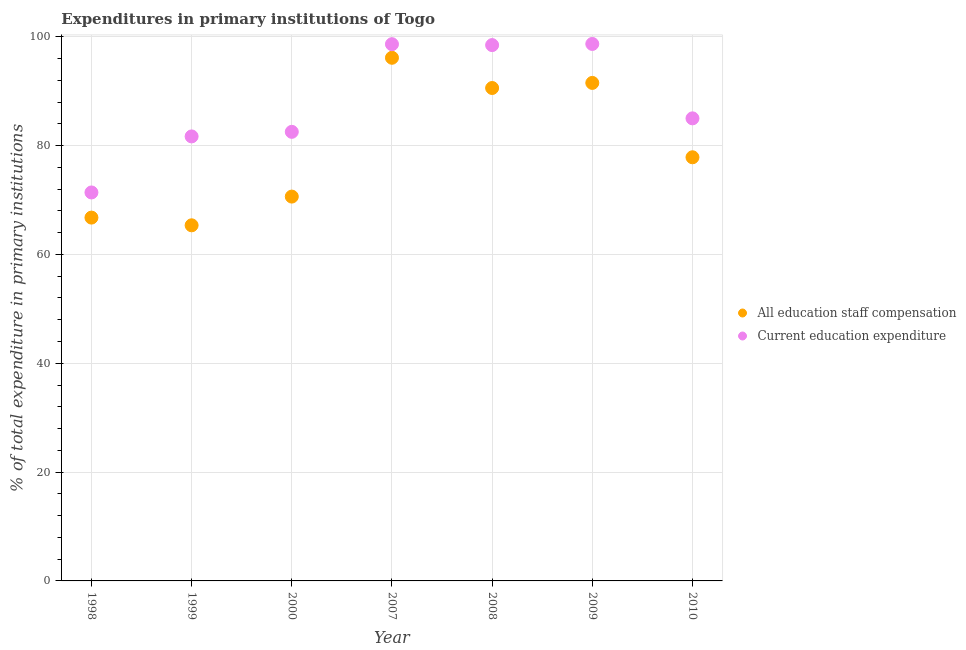How many different coloured dotlines are there?
Your answer should be very brief. 2. What is the expenditure in education in 2009?
Provide a succinct answer. 98.67. Across all years, what is the maximum expenditure in staff compensation?
Your answer should be very brief. 96.13. Across all years, what is the minimum expenditure in staff compensation?
Give a very brief answer. 65.34. In which year was the expenditure in staff compensation maximum?
Offer a terse response. 2007. What is the total expenditure in staff compensation in the graph?
Ensure brevity in your answer.  558.79. What is the difference between the expenditure in staff compensation in 2009 and that in 2010?
Provide a succinct answer. 13.66. What is the difference between the expenditure in education in 1999 and the expenditure in staff compensation in 2009?
Offer a very short reply. -9.83. What is the average expenditure in education per year?
Ensure brevity in your answer.  88.05. In the year 2010, what is the difference between the expenditure in staff compensation and expenditure in education?
Provide a short and direct response. -7.15. In how many years, is the expenditure in education greater than 68 %?
Your answer should be compact. 7. What is the ratio of the expenditure in education in 2000 to that in 2008?
Make the answer very short. 0.84. Is the expenditure in staff compensation in 2007 less than that in 2008?
Offer a very short reply. No. Is the difference between the expenditure in education in 1998 and 2009 greater than the difference between the expenditure in staff compensation in 1998 and 2009?
Your answer should be very brief. No. What is the difference between the highest and the second highest expenditure in education?
Your answer should be very brief. 0.04. What is the difference between the highest and the lowest expenditure in education?
Your answer should be compact. 27.29. In how many years, is the expenditure in staff compensation greater than the average expenditure in staff compensation taken over all years?
Provide a short and direct response. 3. Is the sum of the expenditure in education in 2000 and 2008 greater than the maximum expenditure in staff compensation across all years?
Offer a very short reply. Yes. How many years are there in the graph?
Provide a short and direct response. 7. Where does the legend appear in the graph?
Ensure brevity in your answer.  Center right. How are the legend labels stacked?
Give a very brief answer. Vertical. What is the title of the graph?
Make the answer very short. Expenditures in primary institutions of Togo. Does "Nitrous oxide" appear as one of the legend labels in the graph?
Offer a very short reply. No. What is the label or title of the X-axis?
Make the answer very short. Year. What is the label or title of the Y-axis?
Offer a very short reply. % of total expenditure in primary institutions. What is the % of total expenditure in primary institutions in All education staff compensation in 1998?
Ensure brevity in your answer.  66.76. What is the % of total expenditure in primary institutions of Current education expenditure in 1998?
Your answer should be compact. 71.38. What is the % of total expenditure in primary institutions in All education staff compensation in 1999?
Provide a succinct answer. 65.34. What is the % of total expenditure in primary institutions in Current education expenditure in 1999?
Make the answer very short. 81.68. What is the % of total expenditure in primary institutions in All education staff compensation in 2000?
Your answer should be very brief. 70.62. What is the % of total expenditure in primary institutions of Current education expenditure in 2000?
Your response must be concise. 82.52. What is the % of total expenditure in primary institutions in All education staff compensation in 2007?
Give a very brief answer. 96.13. What is the % of total expenditure in primary institutions in Current education expenditure in 2007?
Your answer should be very brief. 98.63. What is the % of total expenditure in primary institutions of All education staff compensation in 2008?
Provide a succinct answer. 90.57. What is the % of total expenditure in primary institutions in Current education expenditure in 2008?
Your response must be concise. 98.46. What is the % of total expenditure in primary institutions in All education staff compensation in 2009?
Offer a very short reply. 91.51. What is the % of total expenditure in primary institutions of Current education expenditure in 2009?
Give a very brief answer. 98.67. What is the % of total expenditure in primary institutions in All education staff compensation in 2010?
Offer a terse response. 77.85. What is the % of total expenditure in primary institutions of Current education expenditure in 2010?
Offer a very short reply. 85. Across all years, what is the maximum % of total expenditure in primary institutions in All education staff compensation?
Your response must be concise. 96.13. Across all years, what is the maximum % of total expenditure in primary institutions of Current education expenditure?
Provide a short and direct response. 98.67. Across all years, what is the minimum % of total expenditure in primary institutions in All education staff compensation?
Offer a terse response. 65.34. Across all years, what is the minimum % of total expenditure in primary institutions of Current education expenditure?
Provide a short and direct response. 71.38. What is the total % of total expenditure in primary institutions of All education staff compensation in the graph?
Your response must be concise. 558.79. What is the total % of total expenditure in primary institutions in Current education expenditure in the graph?
Your response must be concise. 616.34. What is the difference between the % of total expenditure in primary institutions in All education staff compensation in 1998 and that in 1999?
Make the answer very short. 1.42. What is the difference between the % of total expenditure in primary institutions of Current education expenditure in 1998 and that in 1999?
Offer a terse response. -10.3. What is the difference between the % of total expenditure in primary institutions in All education staff compensation in 1998 and that in 2000?
Offer a terse response. -3.86. What is the difference between the % of total expenditure in primary institutions in Current education expenditure in 1998 and that in 2000?
Offer a terse response. -11.14. What is the difference between the % of total expenditure in primary institutions of All education staff compensation in 1998 and that in 2007?
Your answer should be very brief. -29.37. What is the difference between the % of total expenditure in primary institutions of Current education expenditure in 1998 and that in 2007?
Keep it short and to the point. -27.25. What is the difference between the % of total expenditure in primary institutions of All education staff compensation in 1998 and that in 2008?
Provide a short and direct response. -23.81. What is the difference between the % of total expenditure in primary institutions in Current education expenditure in 1998 and that in 2008?
Your answer should be compact. -27.08. What is the difference between the % of total expenditure in primary institutions of All education staff compensation in 1998 and that in 2009?
Ensure brevity in your answer.  -24.75. What is the difference between the % of total expenditure in primary institutions of Current education expenditure in 1998 and that in 2009?
Make the answer very short. -27.29. What is the difference between the % of total expenditure in primary institutions in All education staff compensation in 1998 and that in 2010?
Your answer should be very brief. -11.08. What is the difference between the % of total expenditure in primary institutions of Current education expenditure in 1998 and that in 2010?
Give a very brief answer. -13.62. What is the difference between the % of total expenditure in primary institutions of All education staff compensation in 1999 and that in 2000?
Your answer should be compact. -5.28. What is the difference between the % of total expenditure in primary institutions in Current education expenditure in 1999 and that in 2000?
Ensure brevity in your answer.  -0.84. What is the difference between the % of total expenditure in primary institutions of All education staff compensation in 1999 and that in 2007?
Make the answer very short. -30.78. What is the difference between the % of total expenditure in primary institutions of Current education expenditure in 1999 and that in 2007?
Offer a very short reply. -16.95. What is the difference between the % of total expenditure in primary institutions in All education staff compensation in 1999 and that in 2008?
Offer a very short reply. -25.23. What is the difference between the % of total expenditure in primary institutions in Current education expenditure in 1999 and that in 2008?
Keep it short and to the point. -16.78. What is the difference between the % of total expenditure in primary institutions of All education staff compensation in 1999 and that in 2009?
Your answer should be very brief. -26.17. What is the difference between the % of total expenditure in primary institutions of Current education expenditure in 1999 and that in 2009?
Make the answer very short. -16.99. What is the difference between the % of total expenditure in primary institutions in All education staff compensation in 1999 and that in 2010?
Keep it short and to the point. -12.5. What is the difference between the % of total expenditure in primary institutions in Current education expenditure in 1999 and that in 2010?
Give a very brief answer. -3.32. What is the difference between the % of total expenditure in primary institutions of All education staff compensation in 2000 and that in 2007?
Offer a terse response. -25.51. What is the difference between the % of total expenditure in primary institutions of Current education expenditure in 2000 and that in 2007?
Keep it short and to the point. -16.11. What is the difference between the % of total expenditure in primary institutions of All education staff compensation in 2000 and that in 2008?
Keep it short and to the point. -19.95. What is the difference between the % of total expenditure in primary institutions of Current education expenditure in 2000 and that in 2008?
Provide a short and direct response. -15.94. What is the difference between the % of total expenditure in primary institutions in All education staff compensation in 2000 and that in 2009?
Your answer should be compact. -20.89. What is the difference between the % of total expenditure in primary institutions in Current education expenditure in 2000 and that in 2009?
Offer a very short reply. -16.15. What is the difference between the % of total expenditure in primary institutions in All education staff compensation in 2000 and that in 2010?
Ensure brevity in your answer.  -7.22. What is the difference between the % of total expenditure in primary institutions of Current education expenditure in 2000 and that in 2010?
Your response must be concise. -2.48. What is the difference between the % of total expenditure in primary institutions of All education staff compensation in 2007 and that in 2008?
Keep it short and to the point. 5.56. What is the difference between the % of total expenditure in primary institutions in Current education expenditure in 2007 and that in 2008?
Offer a terse response. 0.17. What is the difference between the % of total expenditure in primary institutions of All education staff compensation in 2007 and that in 2009?
Your answer should be very brief. 4.62. What is the difference between the % of total expenditure in primary institutions in Current education expenditure in 2007 and that in 2009?
Ensure brevity in your answer.  -0.04. What is the difference between the % of total expenditure in primary institutions in All education staff compensation in 2007 and that in 2010?
Make the answer very short. 18.28. What is the difference between the % of total expenditure in primary institutions in Current education expenditure in 2007 and that in 2010?
Make the answer very short. 13.63. What is the difference between the % of total expenditure in primary institutions in All education staff compensation in 2008 and that in 2009?
Give a very brief answer. -0.94. What is the difference between the % of total expenditure in primary institutions in Current education expenditure in 2008 and that in 2009?
Give a very brief answer. -0.21. What is the difference between the % of total expenditure in primary institutions in All education staff compensation in 2008 and that in 2010?
Your response must be concise. 12.73. What is the difference between the % of total expenditure in primary institutions of Current education expenditure in 2008 and that in 2010?
Your answer should be compact. 13.46. What is the difference between the % of total expenditure in primary institutions of All education staff compensation in 2009 and that in 2010?
Make the answer very short. 13.66. What is the difference between the % of total expenditure in primary institutions in Current education expenditure in 2009 and that in 2010?
Make the answer very short. 13.67. What is the difference between the % of total expenditure in primary institutions of All education staff compensation in 1998 and the % of total expenditure in primary institutions of Current education expenditure in 1999?
Offer a terse response. -14.92. What is the difference between the % of total expenditure in primary institutions of All education staff compensation in 1998 and the % of total expenditure in primary institutions of Current education expenditure in 2000?
Provide a short and direct response. -15.76. What is the difference between the % of total expenditure in primary institutions of All education staff compensation in 1998 and the % of total expenditure in primary institutions of Current education expenditure in 2007?
Your answer should be compact. -31.86. What is the difference between the % of total expenditure in primary institutions of All education staff compensation in 1998 and the % of total expenditure in primary institutions of Current education expenditure in 2008?
Make the answer very short. -31.7. What is the difference between the % of total expenditure in primary institutions of All education staff compensation in 1998 and the % of total expenditure in primary institutions of Current education expenditure in 2009?
Offer a terse response. -31.91. What is the difference between the % of total expenditure in primary institutions of All education staff compensation in 1998 and the % of total expenditure in primary institutions of Current education expenditure in 2010?
Ensure brevity in your answer.  -18.24. What is the difference between the % of total expenditure in primary institutions of All education staff compensation in 1999 and the % of total expenditure in primary institutions of Current education expenditure in 2000?
Provide a short and direct response. -17.18. What is the difference between the % of total expenditure in primary institutions in All education staff compensation in 1999 and the % of total expenditure in primary institutions in Current education expenditure in 2007?
Your answer should be compact. -33.28. What is the difference between the % of total expenditure in primary institutions in All education staff compensation in 1999 and the % of total expenditure in primary institutions in Current education expenditure in 2008?
Your answer should be compact. -33.12. What is the difference between the % of total expenditure in primary institutions of All education staff compensation in 1999 and the % of total expenditure in primary institutions of Current education expenditure in 2009?
Your answer should be compact. -33.33. What is the difference between the % of total expenditure in primary institutions of All education staff compensation in 1999 and the % of total expenditure in primary institutions of Current education expenditure in 2010?
Offer a very short reply. -19.65. What is the difference between the % of total expenditure in primary institutions in All education staff compensation in 2000 and the % of total expenditure in primary institutions in Current education expenditure in 2007?
Provide a short and direct response. -28. What is the difference between the % of total expenditure in primary institutions in All education staff compensation in 2000 and the % of total expenditure in primary institutions in Current education expenditure in 2008?
Offer a terse response. -27.84. What is the difference between the % of total expenditure in primary institutions of All education staff compensation in 2000 and the % of total expenditure in primary institutions of Current education expenditure in 2009?
Offer a terse response. -28.05. What is the difference between the % of total expenditure in primary institutions of All education staff compensation in 2000 and the % of total expenditure in primary institutions of Current education expenditure in 2010?
Provide a short and direct response. -14.38. What is the difference between the % of total expenditure in primary institutions of All education staff compensation in 2007 and the % of total expenditure in primary institutions of Current education expenditure in 2008?
Give a very brief answer. -2.33. What is the difference between the % of total expenditure in primary institutions in All education staff compensation in 2007 and the % of total expenditure in primary institutions in Current education expenditure in 2009?
Give a very brief answer. -2.54. What is the difference between the % of total expenditure in primary institutions of All education staff compensation in 2007 and the % of total expenditure in primary institutions of Current education expenditure in 2010?
Ensure brevity in your answer.  11.13. What is the difference between the % of total expenditure in primary institutions of All education staff compensation in 2008 and the % of total expenditure in primary institutions of Current education expenditure in 2009?
Ensure brevity in your answer.  -8.1. What is the difference between the % of total expenditure in primary institutions in All education staff compensation in 2008 and the % of total expenditure in primary institutions in Current education expenditure in 2010?
Your answer should be very brief. 5.58. What is the difference between the % of total expenditure in primary institutions in All education staff compensation in 2009 and the % of total expenditure in primary institutions in Current education expenditure in 2010?
Your answer should be compact. 6.51. What is the average % of total expenditure in primary institutions in All education staff compensation per year?
Your answer should be very brief. 79.83. What is the average % of total expenditure in primary institutions of Current education expenditure per year?
Your answer should be very brief. 88.05. In the year 1998, what is the difference between the % of total expenditure in primary institutions of All education staff compensation and % of total expenditure in primary institutions of Current education expenditure?
Ensure brevity in your answer.  -4.62. In the year 1999, what is the difference between the % of total expenditure in primary institutions of All education staff compensation and % of total expenditure in primary institutions of Current education expenditure?
Provide a short and direct response. -16.34. In the year 2000, what is the difference between the % of total expenditure in primary institutions in All education staff compensation and % of total expenditure in primary institutions in Current education expenditure?
Your answer should be very brief. -11.9. In the year 2007, what is the difference between the % of total expenditure in primary institutions of All education staff compensation and % of total expenditure in primary institutions of Current education expenditure?
Offer a very short reply. -2.5. In the year 2008, what is the difference between the % of total expenditure in primary institutions of All education staff compensation and % of total expenditure in primary institutions of Current education expenditure?
Make the answer very short. -7.89. In the year 2009, what is the difference between the % of total expenditure in primary institutions of All education staff compensation and % of total expenditure in primary institutions of Current education expenditure?
Your answer should be very brief. -7.16. In the year 2010, what is the difference between the % of total expenditure in primary institutions of All education staff compensation and % of total expenditure in primary institutions of Current education expenditure?
Make the answer very short. -7.15. What is the ratio of the % of total expenditure in primary institutions of All education staff compensation in 1998 to that in 1999?
Ensure brevity in your answer.  1.02. What is the ratio of the % of total expenditure in primary institutions in Current education expenditure in 1998 to that in 1999?
Provide a succinct answer. 0.87. What is the ratio of the % of total expenditure in primary institutions in All education staff compensation in 1998 to that in 2000?
Your answer should be very brief. 0.95. What is the ratio of the % of total expenditure in primary institutions in Current education expenditure in 1998 to that in 2000?
Offer a terse response. 0.86. What is the ratio of the % of total expenditure in primary institutions of All education staff compensation in 1998 to that in 2007?
Offer a very short reply. 0.69. What is the ratio of the % of total expenditure in primary institutions in Current education expenditure in 1998 to that in 2007?
Provide a short and direct response. 0.72. What is the ratio of the % of total expenditure in primary institutions in All education staff compensation in 1998 to that in 2008?
Ensure brevity in your answer.  0.74. What is the ratio of the % of total expenditure in primary institutions of Current education expenditure in 1998 to that in 2008?
Provide a succinct answer. 0.72. What is the ratio of the % of total expenditure in primary institutions of All education staff compensation in 1998 to that in 2009?
Provide a short and direct response. 0.73. What is the ratio of the % of total expenditure in primary institutions in Current education expenditure in 1998 to that in 2009?
Your response must be concise. 0.72. What is the ratio of the % of total expenditure in primary institutions of All education staff compensation in 1998 to that in 2010?
Offer a terse response. 0.86. What is the ratio of the % of total expenditure in primary institutions of Current education expenditure in 1998 to that in 2010?
Offer a very short reply. 0.84. What is the ratio of the % of total expenditure in primary institutions in All education staff compensation in 1999 to that in 2000?
Make the answer very short. 0.93. What is the ratio of the % of total expenditure in primary institutions in All education staff compensation in 1999 to that in 2007?
Your response must be concise. 0.68. What is the ratio of the % of total expenditure in primary institutions in Current education expenditure in 1999 to that in 2007?
Give a very brief answer. 0.83. What is the ratio of the % of total expenditure in primary institutions of All education staff compensation in 1999 to that in 2008?
Provide a succinct answer. 0.72. What is the ratio of the % of total expenditure in primary institutions in Current education expenditure in 1999 to that in 2008?
Offer a terse response. 0.83. What is the ratio of the % of total expenditure in primary institutions in All education staff compensation in 1999 to that in 2009?
Ensure brevity in your answer.  0.71. What is the ratio of the % of total expenditure in primary institutions in Current education expenditure in 1999 to that in 2009?
Your answer should be very brief. 0.83. What is the ratio of the % of total expenditure in primary institutions in All education staff compensation in 1999 to that in 2010?
Keep it short and to the point. 0.84. What is the ratio of the % of total expenditure in primary institutions in Current education expenditure in 1999 to that in 2010?
Make the answer very short. 0.96. What is the ratio of the % of total expenditure in primary institutions of All education staff compensation in 2000 to that in 2007?
Make the answer very short. 0.73. What is the ratio of the % of total expenditure in primary institutions of Current education expenditure in 2000 to that in 2007?
Provide a succinct answer. 0.84. What is the ratio of the % of total expenditure in primary institutions of All education staff compensation in 2000 to that in 2008?
Ensure brevity in your answer.  0.78. What is the ratio of the % of total expenditure in primary institutions in Current education expenditure in 2000 to that in 2008?
Your answer should be very brief. 0.84. What is the ratio of the % of total expenditure in primary institutions in All education staff compensation in 2000 to that in 2009?
Keep it short and to the point. 0.77. What is the ratio of the % of total expenditure in primary institutions in Current education expenditure in 2000 to that in 2009?
Your answer should be very brief. 0.84. What is the ratio of the % of total expenditure in primary institutions of All education staff compensation in 2000 to that in 2010?
Make the answer very short. 0.91. What is the ratio of the % of total expenditure in primary institutions in Current education expenditure in 2000 to that in 2010?
Ensure brevity in your answer.  0.97. What is the ratio of the % of total expenditure in primary institutions of All education staff compensation in 2007 to that in 2008?
Your response must be concise. 1.06. What is the ratio of the % of total expenditure in primary institutions of Current education expenditure in 2007 to that in 2008?
Give a very brief answer. 1. What is the ratio of the % of total expenditure in primary institutions in All education staff compensation in 2007 to that in 2009?
Your answer should be compact. 1.05. What is the ratio of the % of total expenditure in primary institutions in All education staff compensation in 2007 to that in 2010?
Give a very brief answer. 1.23. What is the ratio of the % of total expenditure in primary institutions of Current education expenditure in 2007 to that in 2010?
Offer a very short reply. 1.16. What is the ratio of the % of total expenditure in primary institutions in All education staff compensation in 2008 to that in 2009?
Provide a succinct answer. 0.99. What is the ratio of the % of total expenditure in primary institutions in All education staff compensation in 2008 to that in 2010?
Ensure brevity in your answer.  1.16. What is the ratio of the % of total expenditure in primary institutions in Current education expenditure in 2008 to that in 2010?
Make the answer very short. 1.16. What is the ratio of the % of total expenditure in primary institutions of All education staff compensation in 2009 to that in 2010?
Provide a short and direct response. 1.18. What is the ratio of the % of total expenditure in primary institutions in Current education expenditure in 2009 to that in 2010?
Offer a terse response. 1.16. What is the difference between the highest and the second highest % of total expenditure in primary institutions in All education staff compensation?
Make the answer very short. 4.62. What is the difference between the highest and the second highest % of total expenditure in primary institutions of Current education expenditure?
Your response must be concise. 0.04. What is the difference between the highest and the lowest % of total expenditure in primary institutions of All education staff compensation?
Give a very brief answer. 30.78. What is the difference between the highest and the lowest % of total expenditure in primary institutions of Current education expenditure?
Give a very brief answer. 27.29. 